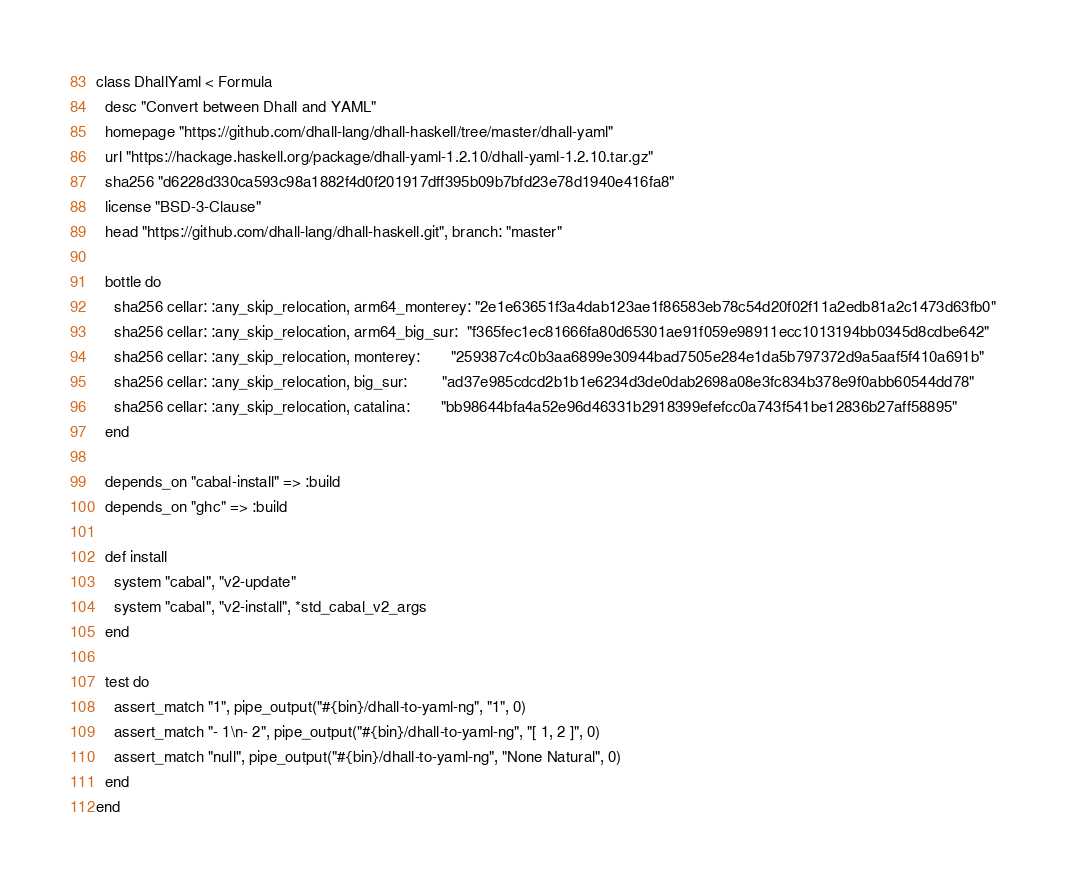Convert code to text. <code><loc_0><loc_0><loc_500><loc_500><_Ruby_>class DhallYaml < Formula
  desc "Convert between Dhall and YAML"
  homepage "https://github.com/dhall-lang/dhall-haskell/tree/master/dhall-yaml"
  url "https://hackage.haskell.org/package/dhall-yaml-1.2.10/dhall-yaml-1.2.10.tar.gz"
  sha256 "d6228d330ca593c98a1882f4d0f201917dff395b09b7bfd23e78d1940e416fa8"
  license "BSD-3-Clause"
  head "https://github.com/dhall-lang/dhall-haskell.git", branch: "master"

  bottle do
    sha256 cellar: :any_skip_relocation, arm64_monterey: "2e1e63651f3a4dab123ae1f86583eb78c54d20f02f11a2edb81a2c1473d63fb0"
    sha256 cellar: :any_skip_relocation, arm64_big_sur:  "f365fec1ec81666fa80d65301ae91f059e98911ecc1013194bb0345d8cdbe642"
    sha256 cellar: :any_skip_relocation, monterey:       "259387c4c0b3aa6899e30944bad7505e284e1da5b797372d9a5aaf5f410a691b"
    sha256 cellar: :any_skip_relocation, big_sur:        "ad37e985cdcd2b1b1e6234d3de0dab2698a08e3fc834b378e9f0abb60544dd78"
    sha256 cellar: :any_skip_relocation, catalina:       "bb98644bfa4a52e96d46331b2918399efefcc0a743f541be12836b27aff58895"
  end

  depends_on "cabal-install" => :build
  depends_on "ghc" => :build

  def install
    system "cabal", "v2-update"
    system "cabal", "v2-install", *std_cabal_v2_args
  end

  test do
    assert_match "1", pipe_output("#{bin}/dhall-to-yaml-ng", "1", 0)
    assert_match "- 1\n- 2", pipe_output("#{bin}/dhall-to-yaml-ng", "[ 1, 2 ]", 0)
    assert_match "null", pipe_output("#{bin}/dhall-to-yaml-ng", "None Natural", 0)
  end
end
</code> 